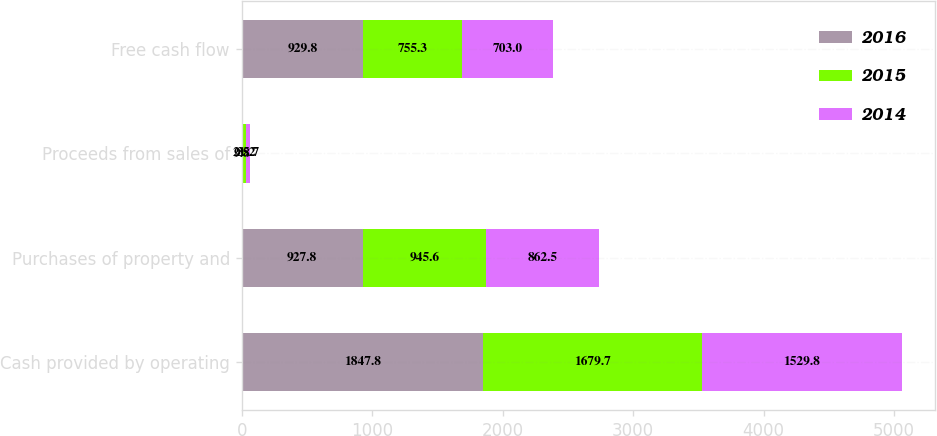Convert chart to OTSL. <chart><loc_0><loc_0><loc_500><loc_500><stacked_bar_chart><ecel><fcel>Cash provided by operating<fcel>Purchases of property and<fcel>Proceeds from sales of<fcel>Free cash flow<nl><fcel>2016<fcel>1847.8<fcel>927.8<fcel>9.8<fcel>929.8<nl><fcel>2015<fcel>1679.7<fcel>945.6<fcel>21.2<fcel>755.3<nl><fcel>2014<fcel>1529.8<fcel>862.5<fcel>35.7<fcel>703<nl></chart> 